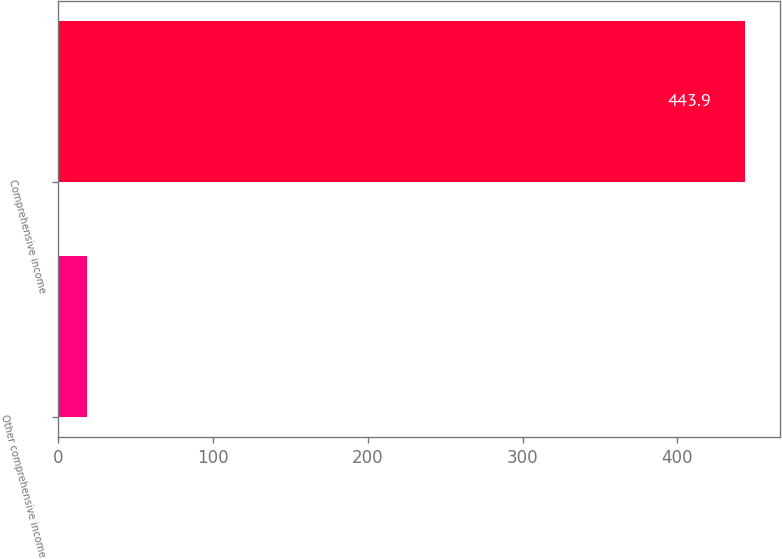<chart> <loc_0><loc_0><loc_500><loc_500><bar_chart><fcel>Other comprehensive income<fcel>Comprehensive income<nl><fcel>18.5<fcel>443.9<nl></chart> 